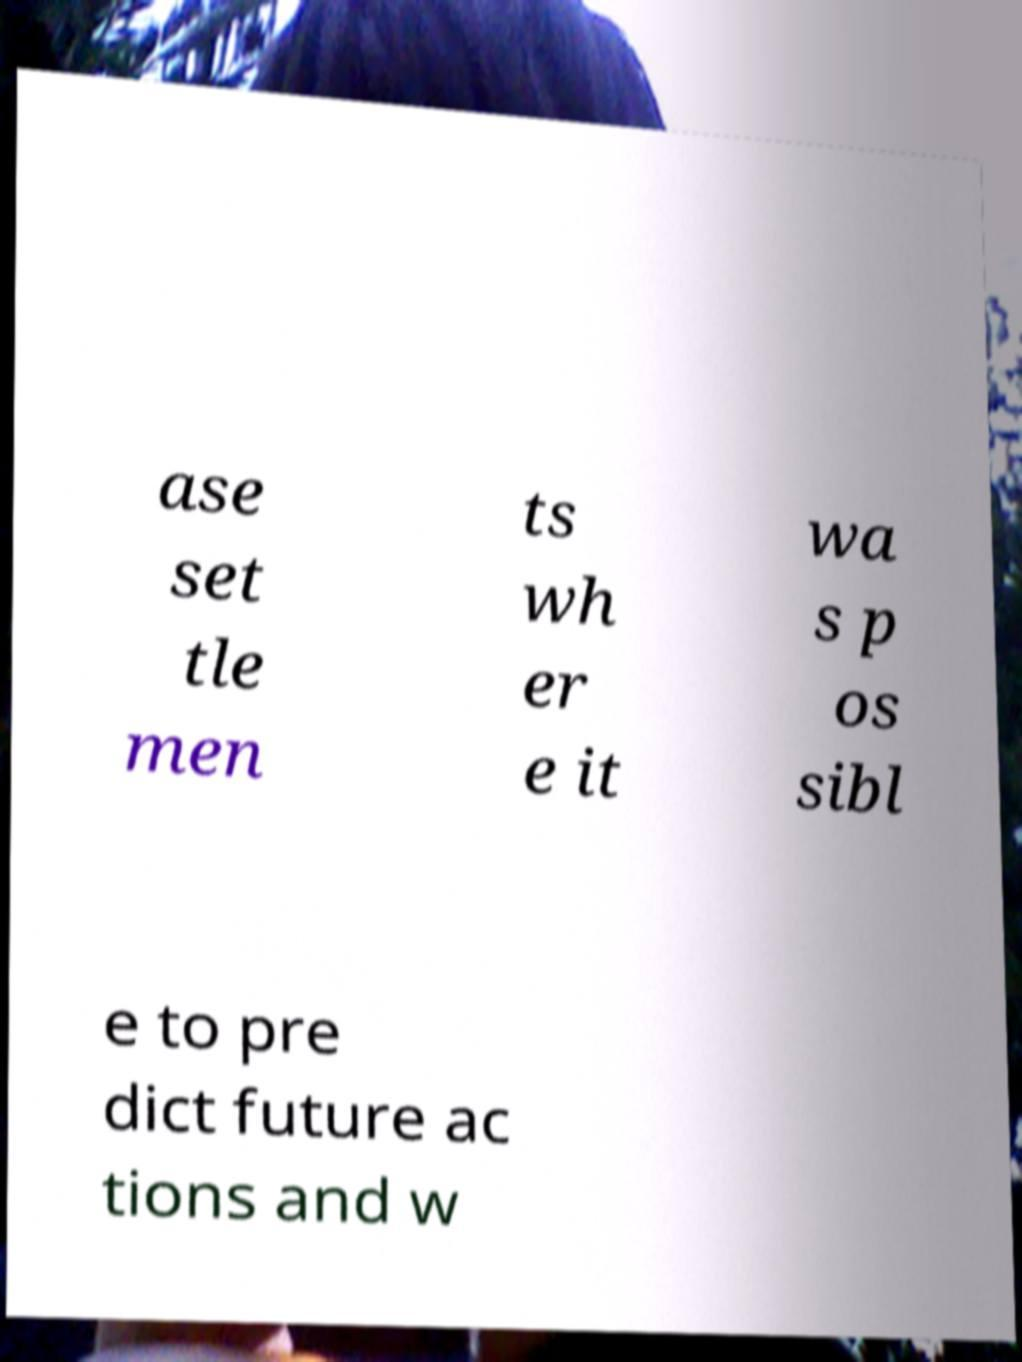There's text embedded in this image that I need extracted. Can you transcribe it verbatim? ase set tle men ts wh er e it wa s p os sibl e to pre dict future ac tions and w 